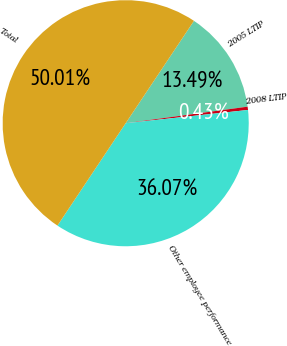<chart> <loc_0><loc_0><loc_500><loc_500><pie_chart><fcel>2005 LTIP<fcel>2008 LTIP<fcel>Other employee performance<fcel>Total<nl><fcel>13.49%<fcel>0.43%<fcel>36.07%<fcel>50.0%<nl></chart> 